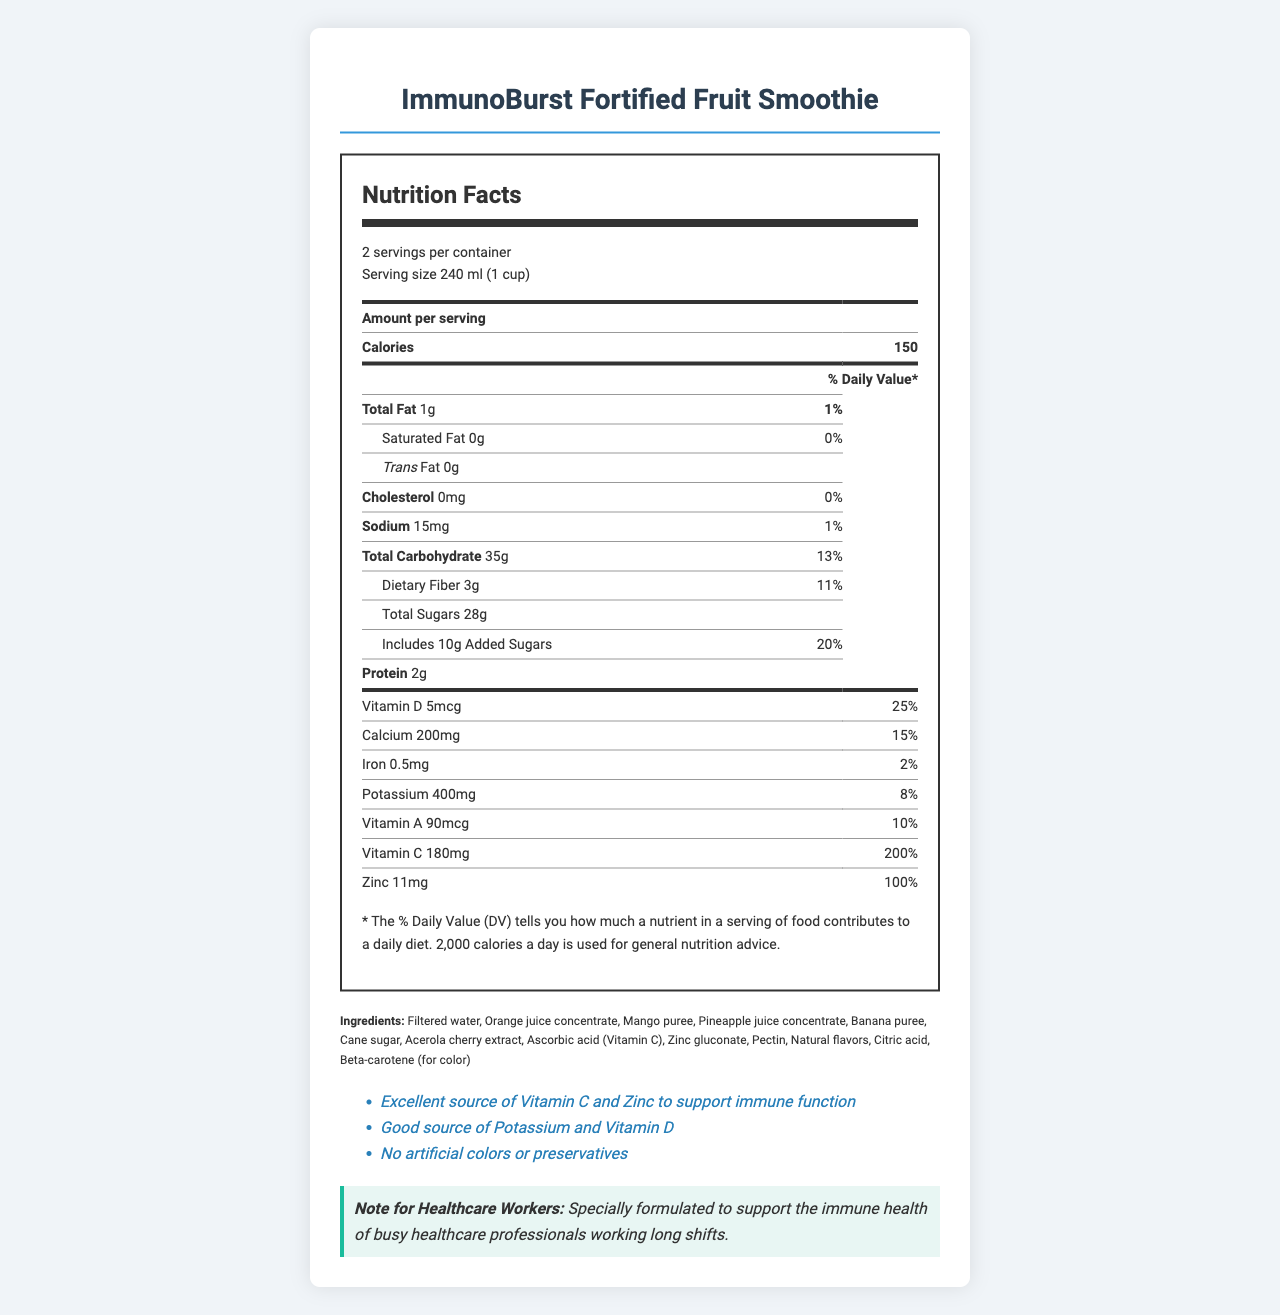how many calories are in one serving? The nutrition label states that each serving contains 150 calories.
Answer: 150 what is the serving size? The serving size is listed as 240 ml, which is equivalent to 1 cup.
Answer: 240 ml (1 cup) how many servings are in the container? The document states there are 2 servings per container.
Answer: 2 what percentage of the daily value of Vitamin C does one serving provide? The document states that one serving provides 200% of the daily value for Vitamin C.
Answer: 200% what is the total amount of fat in one serving? The nutrition label states that there is 1g of total fat in one serving.
Answer: 1g how much sodium is in one serving? The document lists 15mg of sodium per serving.
Answer: 15mg which ingredient provides the main source of Vitamin C? According to the ingredient list, ascorbic acid is a source of Vitamin C.
Answer: Ascorbic acid (Vitamin C) what is the total amount of dietary fiber in one serving? A. 2g B. 3g C. 5g The nutrition label lists 3g of dietary fiber per serving.
Answer: B how much Zinc does one serving contain? The document specifies that one serving contains 11mg of zinc.
Answer: 11mg which of the following minerals is present at 15% daily value per serving? A. Calcium B. Iron C. Potassium The nutrition label lists calcium at 15% daily value per serving.
Answer: A is there any cholesterol in one serving? The nutrition label states that the product contains 0mg of cholesterol per serving.
Answer: No summarize the main idea of the document. The ImmunoBurst Fortified Fruit Smoothie is marketed to boost immune function, particularly for healthcare professionals. It offers a rich source of Vitamin C and Zinc, and emphasizes natural ingredients without artificial colors or preservatives.
Answer: The ImmunoBurst Fortified Fruit Smoothie is a health drink specifically designed for healthcare workers, providing high levels of Vitamin C and Zinc to support immune function. The product contains natural ingredients and offers various health benefits, including a good source of potassium and Vitamin D. The label includes detailed nutritional content, ingredient list, health claims, storage instructions, and manufacturer information. what is the manufacturer's address? The manufacturer's address is listed in the document as HealthCare Nutrition Inc., San Francisco, CA 94110.
Answer: HealthCare Nutrition Inc., San Francisco, CA 94110 does the product contain any added sugars? The document states that the product includes 10g of added sugars per serving.
Answer: Yes what are the storage instructions for the product? The storage instructions are to keep the product refrigerated and to consume it within 7 days after opening.
Answer: Keep refrigerated. Consume within 7 days after opening. how long can the product be kept after opening? The storage instructions specify that the product should be consumed within 7 days after opening.
Answer: 7 days what is the main health claim made about the product? One of the main health claims listed is that the product is an excellent source of Vitamin C and Zinc to support immune function.
Answer: Excellent source of Vitamin C and Zinc to support immune function is the product suitable for someone with a tree nut allergy? The document states that the product is produced in a facility that processes tree nuts, but does not provide sufficient information to determine if it is safe for someone with a tree nut allergy.
Answer: Cannot be determined 